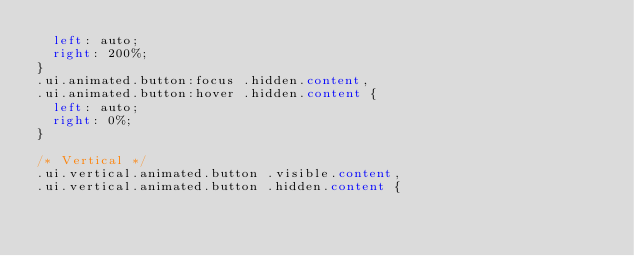<code> <loc_0><loc_0><loc_500><loc_500><_CSS_>  left: auto;
  right: 200%;
}
.ui.animated.button:focus .hidden.content,
.ui.animated.button:hover .hidden.content {
  left: auto;
  right: 0%;
}

/* Vertical */
.ui.vertical.animated.button .visible.content,
.ui.vertical.animated.button .hidden.content {</code> 